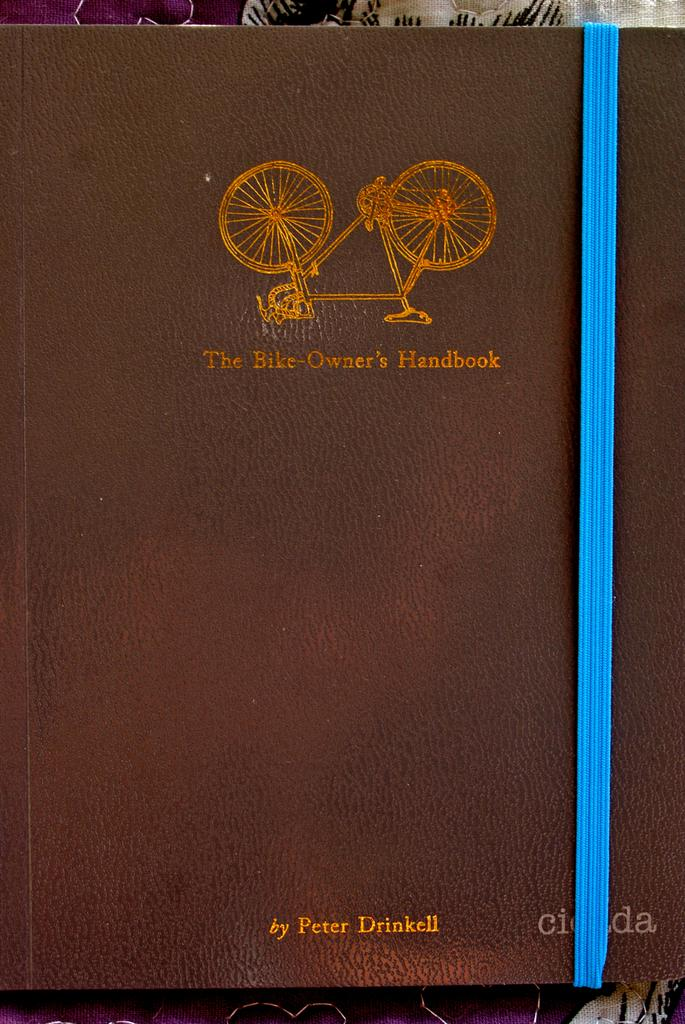<image>
Present a compact description of the photo's key features. A leather bound book titled The Bike-Owner's Handbook 